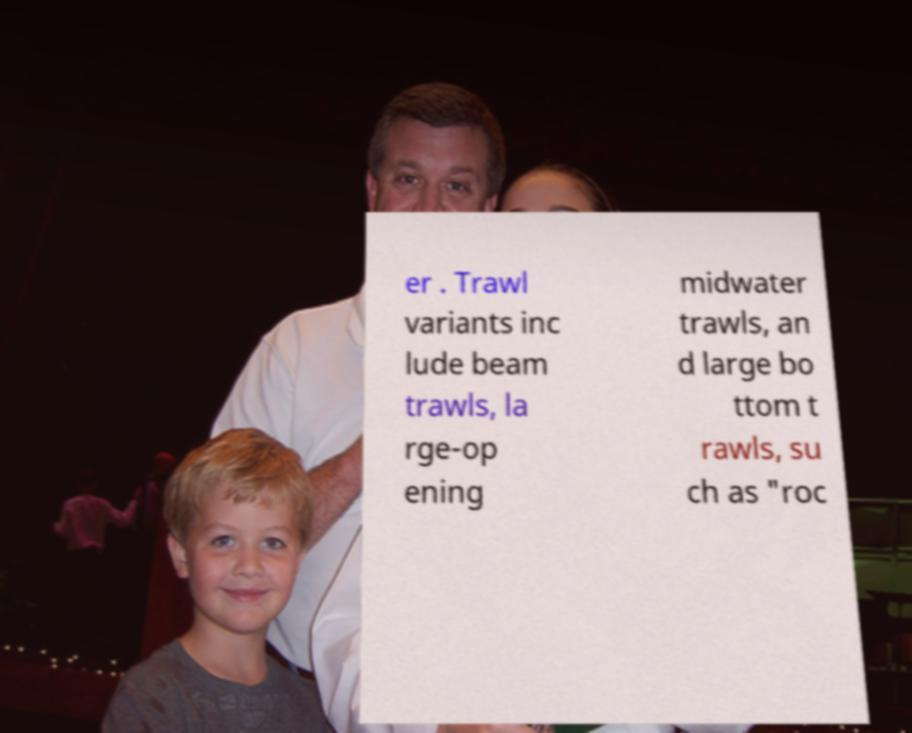Could you extract and type out the text from this image? er . Trawl variants inc lude beam trawls, la rge-op ening midwater trawls, an d large bo ttom t rawls, su ch as "roc 